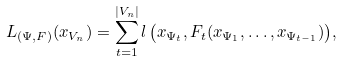Convert formula to latex. <formula><loc_0><loc_0><loc_500><loc_500>L _ { ( \Psi , F ) } ( x _ { V _ { n } } ) = \sum _ { t = 1 } ^ { | V _ { n } | } { l \left ( x _ { \Psi _ { t } } , F _ { t } ( x _ { \Psi _ { 1 } } , \dots , x _ { \Psi _ { t - 1 } } ) \right ) } ,</formula> 